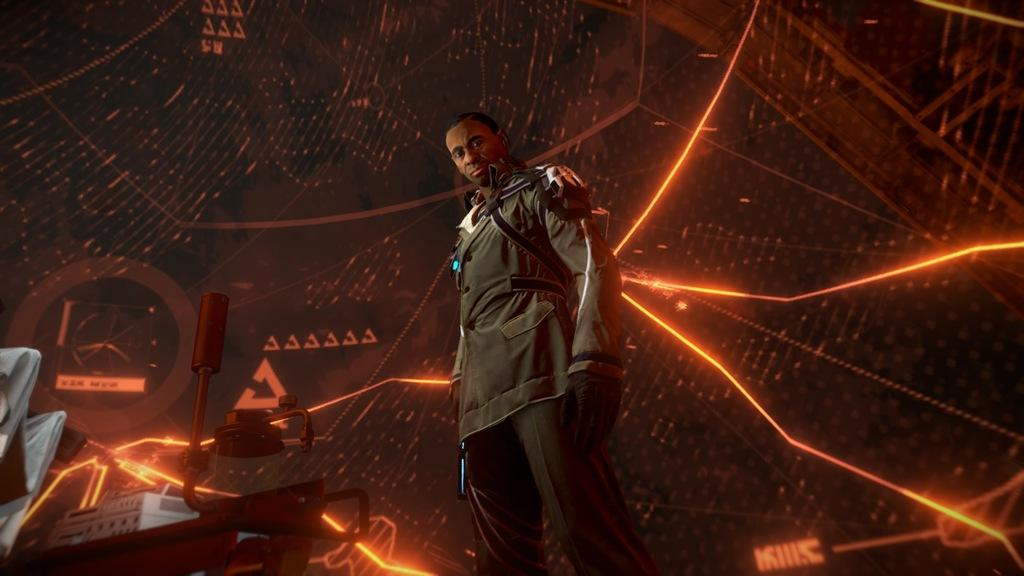Who is the main subject in the image? There is a man in the middle of the image. What is the man wearing? The man is wearing a jacket and trousers. What is the man doing in the image? The man is standing. What can be seen on the left side of the image? There are machines and chairs on the left side of the image. What is visible in the background of the image? There is a screen in the background of the image. Can you see a lake in the image? No, there is no lake present in the image. What type of stick is the man holding in the image? There is no stick present in the image; the man is not holding anything. 